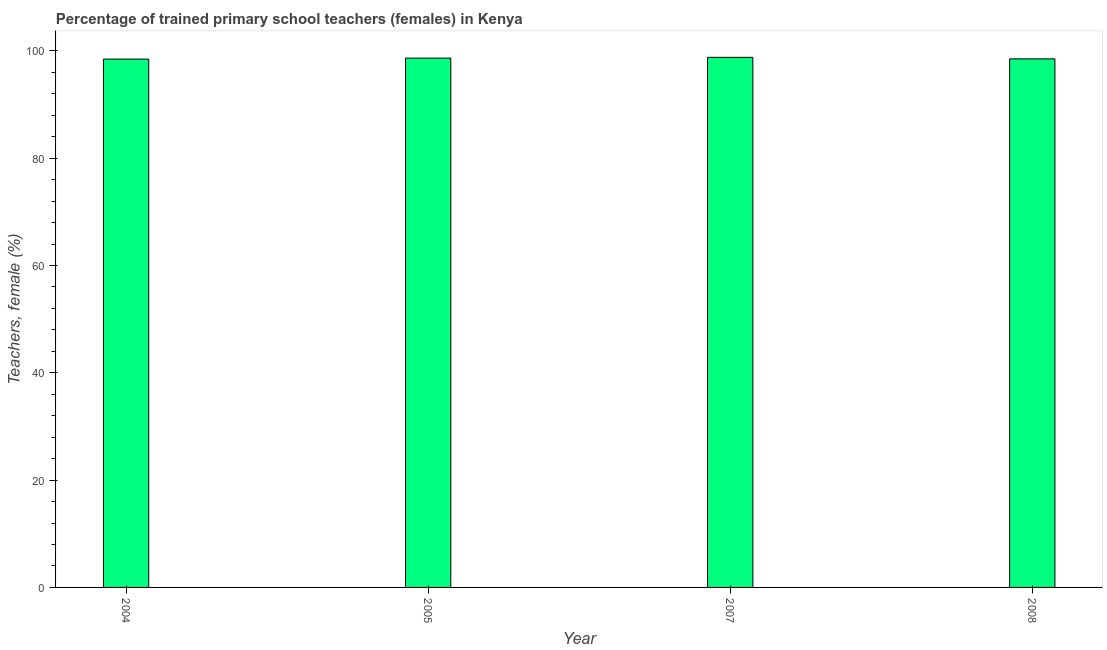Does the graph contain any zero values?
Your response must be concise. No. Does the graph contain grids?
Offer a terse response. No. What is the title of the graph?
Your answer should be compact. Percentage of trained primary school teachers (females) in Kenya. What is the label or title of the Y-axis?
Make the answer very short. Teachers, female (%). What is the percentage of trained female teachers in 2008?
Provide a short and direct response. 98.52. Across all years, what is the maximum percentage of trained female teachers?
Ensure brevity in your answer.  98.81. Across all years, what is the minimum percentage of trained female teachers?
Make the answer very short. 98.47. In which year was the percentage of trained female teachers maximum?
Ensure brevity in your answer.  2007. In which year was the percentage of trained female teachers minimum?
Offer a terse response. 2004. What is the sum of the percentage of trained female teachers?
Provide a succinct answer. 394.46. What is the difference between the percentage of trained female teachers in 2004 and 2008?
Your answer should be very brief. -0.05. What is the average percentage of trained female teachers per year?
Ensure brevity in your answer.  98.62. What is the median percentage of trained female teachers?
Your answer should be very brief. 98.59. Do a majority of the years between 2004 and 2005 (inclusive) have percentage of trained female teachers greater than 4 %?
Your answer should be very brief. Yes. Is the percentage of trained female teachers in 2004 less than that in 2005?
Provide a succinct answer. Yes. What is the difference between the highest and the second highest percentage of trained female teachers?
Offer a terse response. 0.14. What is the difference between the highest and the lowest percentage of trained female teachers?
Make the answer very short. 0.33. In how many years, is the percentage of trained female teachers greater than the average percentage of trained female teachers taken over all years?
Make the answer very short. 2. How many bars are there?
Offer a terse response. 4. What is the difference between two consecutive major ticks on the Y-axis?
Ensure brevity in your answer.  20. What is the Teachers, female (%) in 2004?
Give a very brief answer. 98.47. What is the Teachers, female (%) in 2005?
Provide a short and direct response. 98.66. What is the Teachers, female (%) of 2007?
Your answer should be very brief. 98.81. What is the Teachers, female (%) of 2008?
Provide a succinct answer. 98.52. What is the difference between the Teachers, female (%) in 2004 and 2005?
Provide a short and direct response. -0.19. What is the difference between the Teachers, female (%) in 2004 and 2007?
Ensure brevity in your answer.  -0.33. What is the difference between the Teachers, female (%) in 2004 and 2008?
Provide a short and direct response. -0.05. What is the difference between the Teachers, female (%) in 2005 and 2007?
Your answer should be compact. -0.15. What is the difference between the Teachers, female (%) in 2005 and 2008?
Your response must be concise. 0.14. What is the difference between the Teachers, female (%) in 2007 and 2008?
Keep it short and to the point. 0.29. What is the ratio of the Teachers, female (%) in 2004 to that in 2007?
Keep it short and to the point. 1. What is the ratio of the Teachers, female (%) in 2004 to that in 2008?
Your answer should be very brief. 1. What is the ratio of the Teachers, female (%) in 2007 to that in 2008?
Provide a succinct answer. 1. 